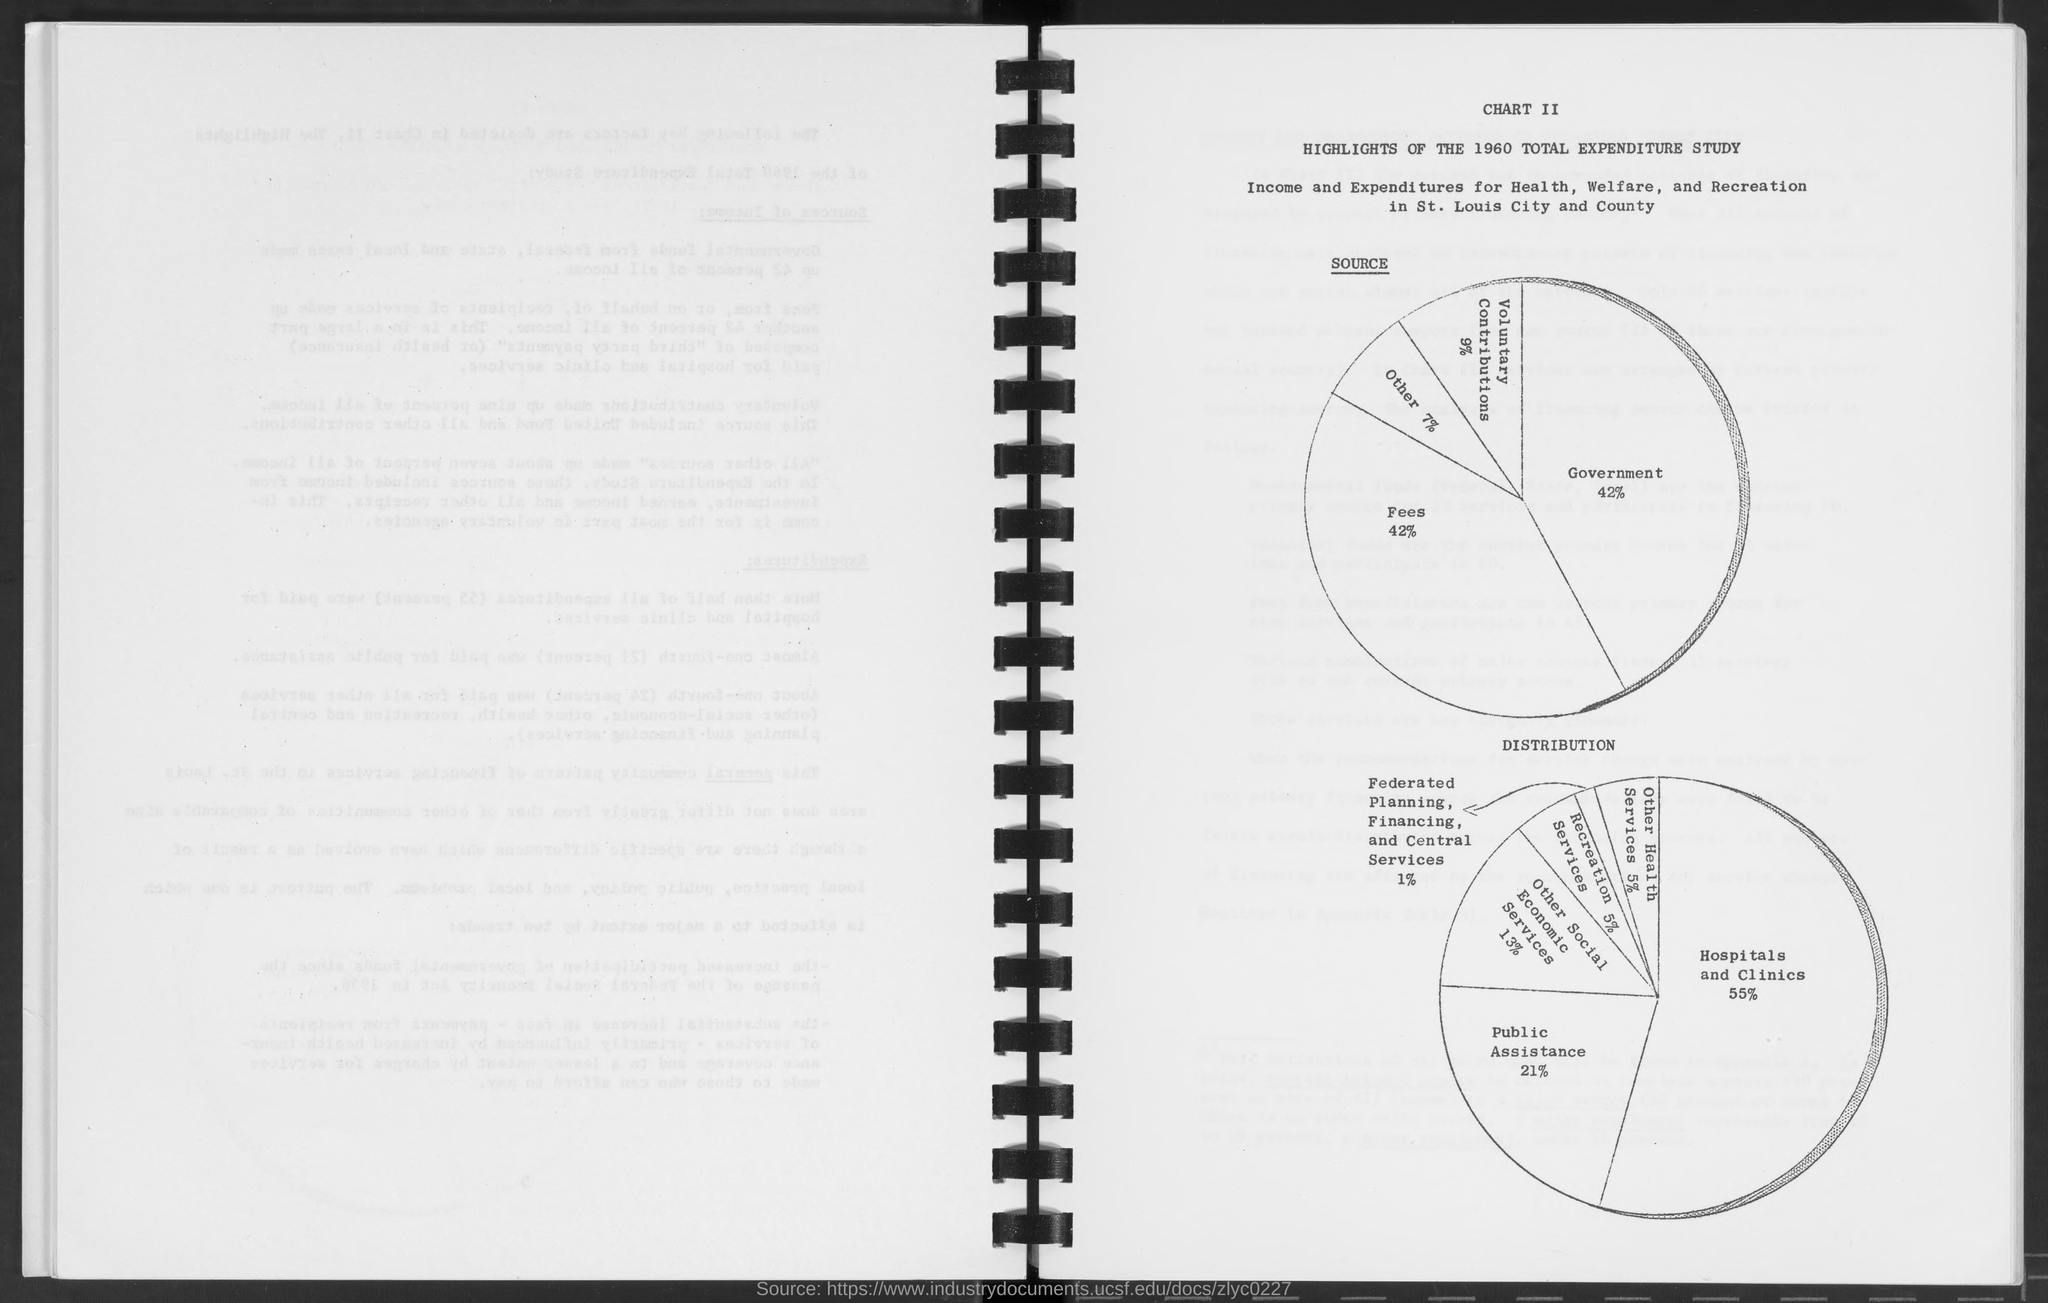What is the historical context of this document? The document seems to be a page from a report, possibly belonging to a study from 1960 regarding the total expenditures for Health, Welfare, and Recreation in St. Louis City and County. Such documents typically provide insight into public funding allocation and financial priorities of the time, reflecting the socioeconomic focus areas of the local government during that period. 